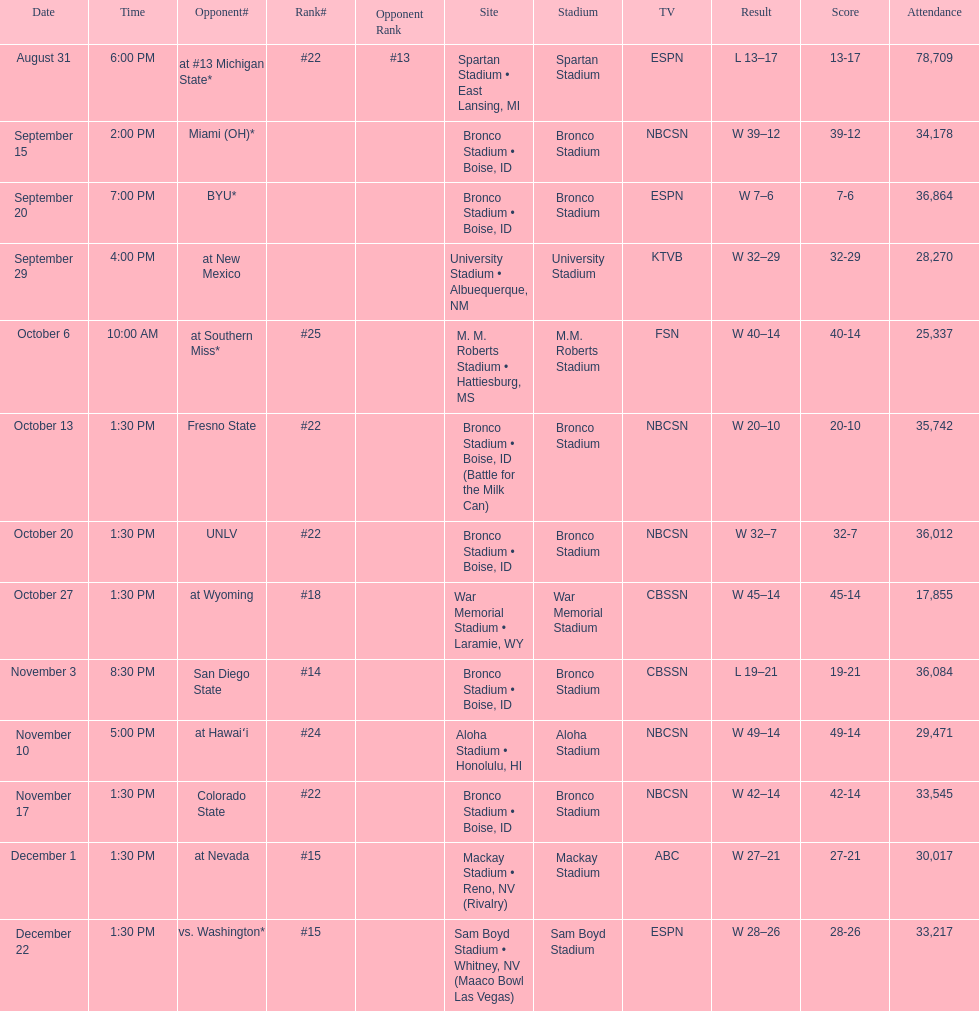Following november 10th, at which rank was boise state placed? #22. 